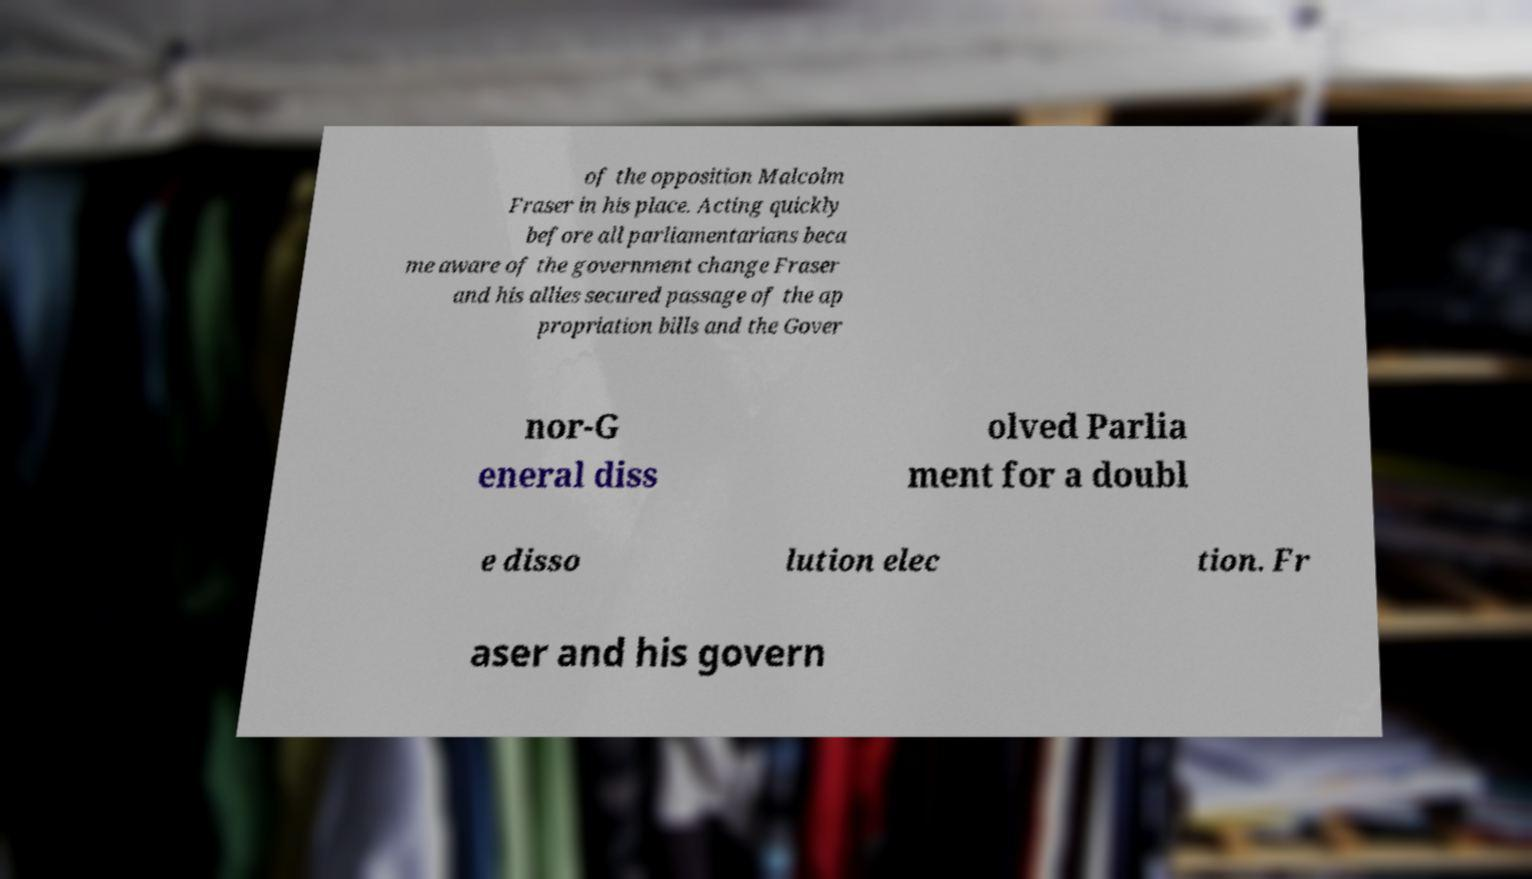Could you extract and type out the text from this image? of the opposition Malcolm Fraser in his place. Acting quickly before all parliamentarians beca me aware of the government change Fraser and his allies secured passage of the ap propriation bills and the Gover nor-G eneral diss olved Parlia ment for a doubl e disso lution elec tion. Fr aser and his govern 